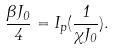<formula> <loc_0><loc_0><loc_500><loc_500>\frac { \beta J _ { 0 } } { 4 } = I _ { p } ( \frac { 1 } { \chi J _ { 0 } } ) .</formula> 